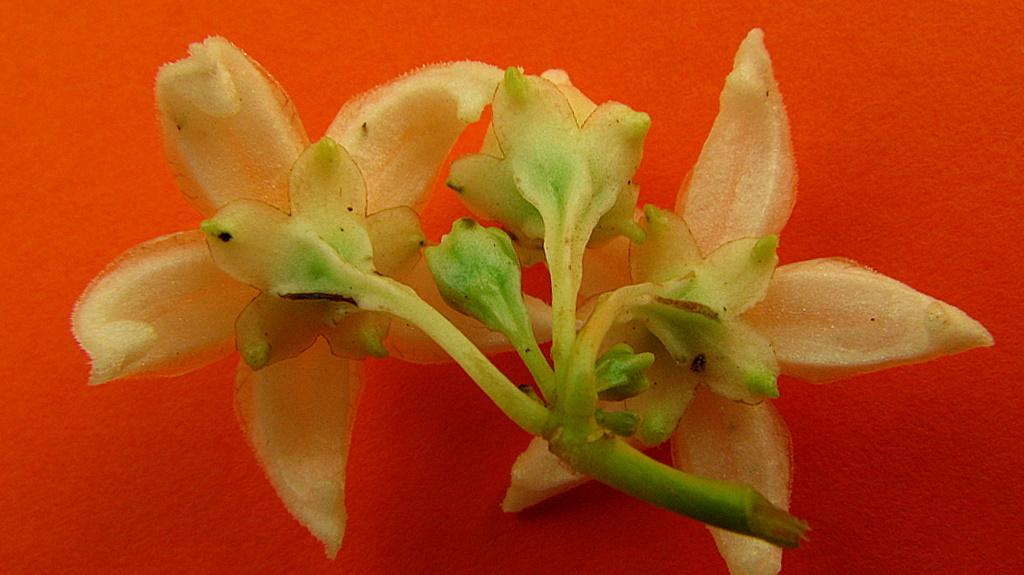What type of flowers can be seen in the image? There are white color flowers in the image. What grade does the flower receive for its performance in the image? There is no grading system or performance evaluation for flowers in the image. Flowers do not have the ability to perform or receive grades. 